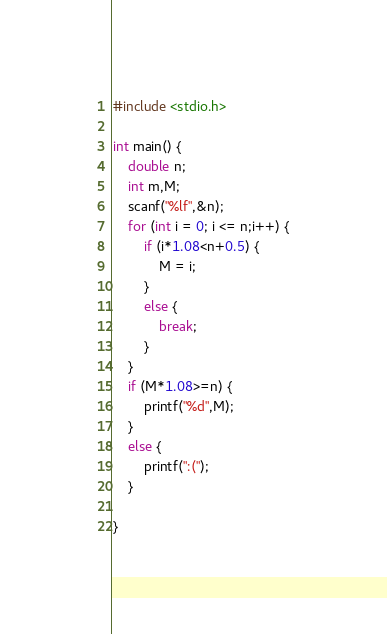<code> <loc_0><loc_0><loc_500><loc_500><_C_>#include <stdio.h>

int main() {
	double n;
	int m,M;
	scanf("%lf",&n);
	for (int i = 0; i <= n;i++) {
		if (i*1.08<n+0.5) {
			M = i;
		}
		else {
			break;
		}
	}
	if (M*1.08>=n) {
		printf("%d",M);
	}
	else {
		printf(":(");
	}

}</code> 